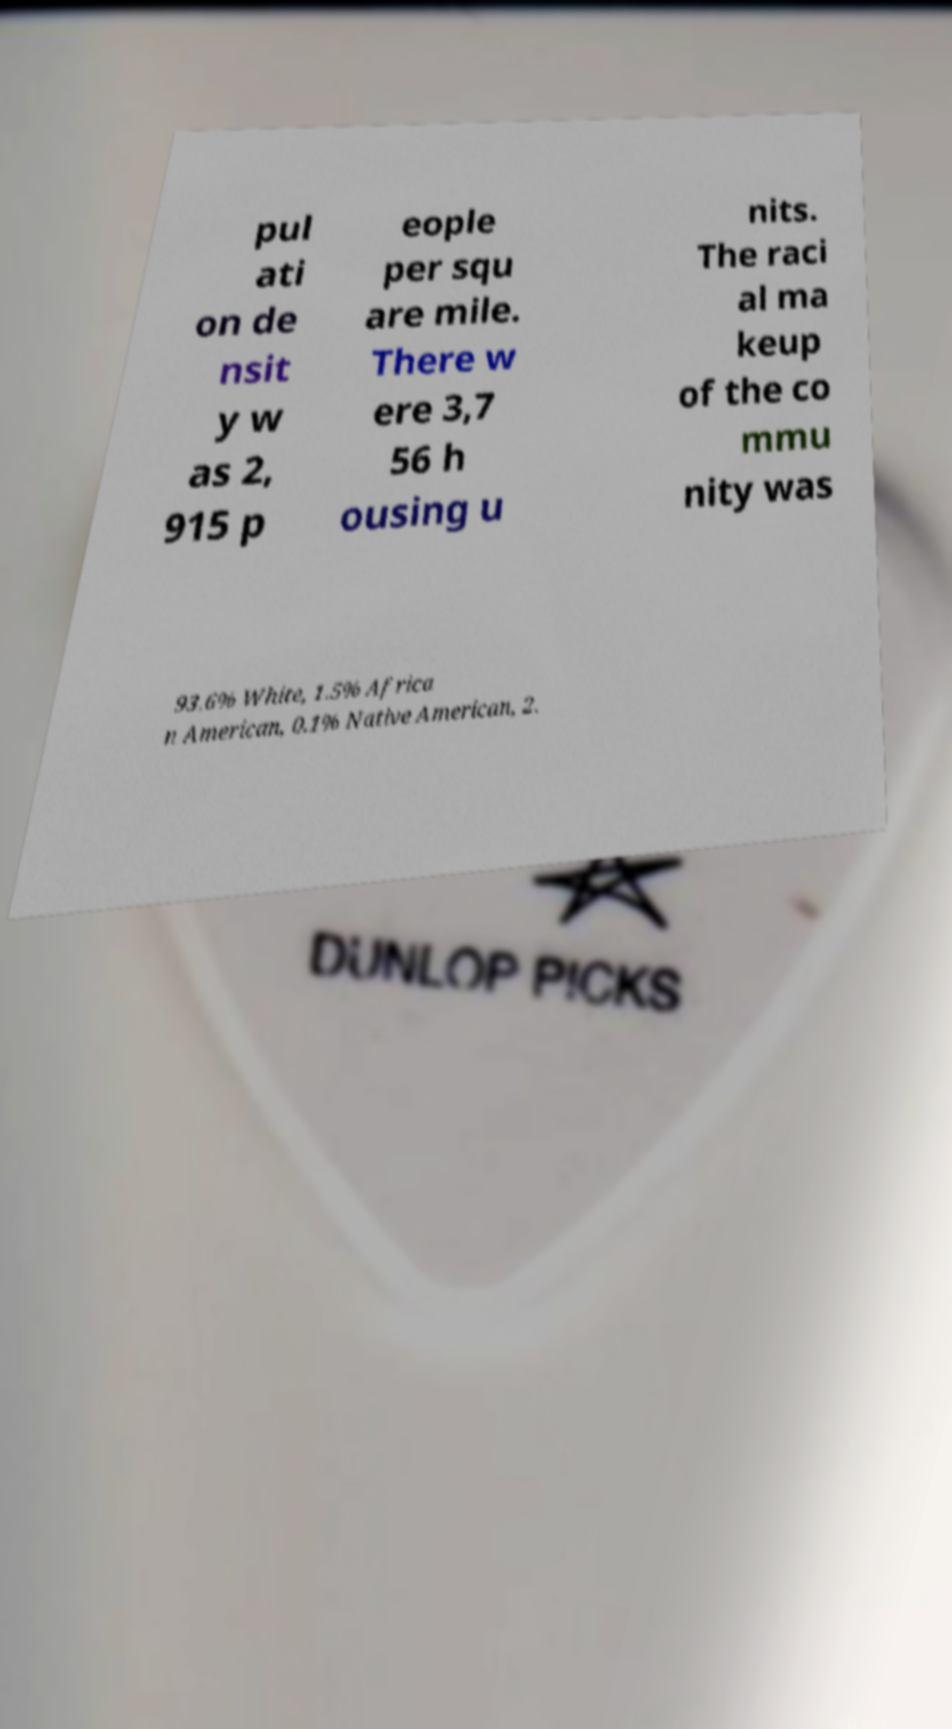There's text embedded in this image that I need extracted. Can you transcribe it verbatim? pul ati on de nsit y w as 2, 915 p eople per squ are mile. There w ere 3,7 56 h ousing u nits. The raci al ma keup of the co mmu nity was 93.6% White, 1.5% Africa n American, 0.1% Native American, 2. 